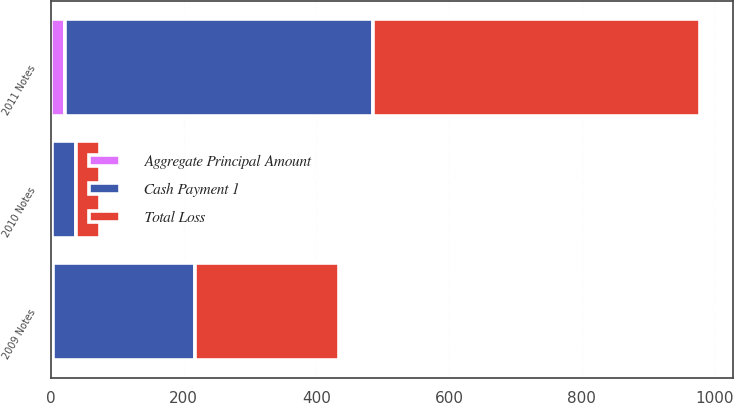Convert chart to OTSL. <chart><loc_0><loc_0><loc_500><loc_500><stacked_bar_chart><ecel><fcel>2009 Notes<fcel>2011 Notes<fcel>2010 Notes<nl><fcel>Cash Payment 1<fcel>214<fcel>463.7<fcel>36.3<nl><fcel>Total Loss<fcel>217.3<fcel>494.2<fcel>36.4<nl><fcel>Aggregate Principal Amount<fcel>3<fcel>21.5<fcel>0.9<nl></chart> 